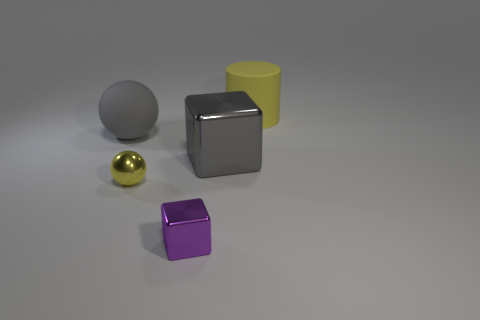What number of balls have the same material as the purple cube? Upon examining the image, it appears that none of the balls share the exact material with the purple cube. However, if we consider the similarity in the specular finish, one ball—the golden one—has a similar reflective property, but this does not necessarily mean the material is the same. Materials can have similar finishes but different colors or other properties, so with the information available in the image, it's accurate to say none of the balls are made of the same material as the purple cube. 